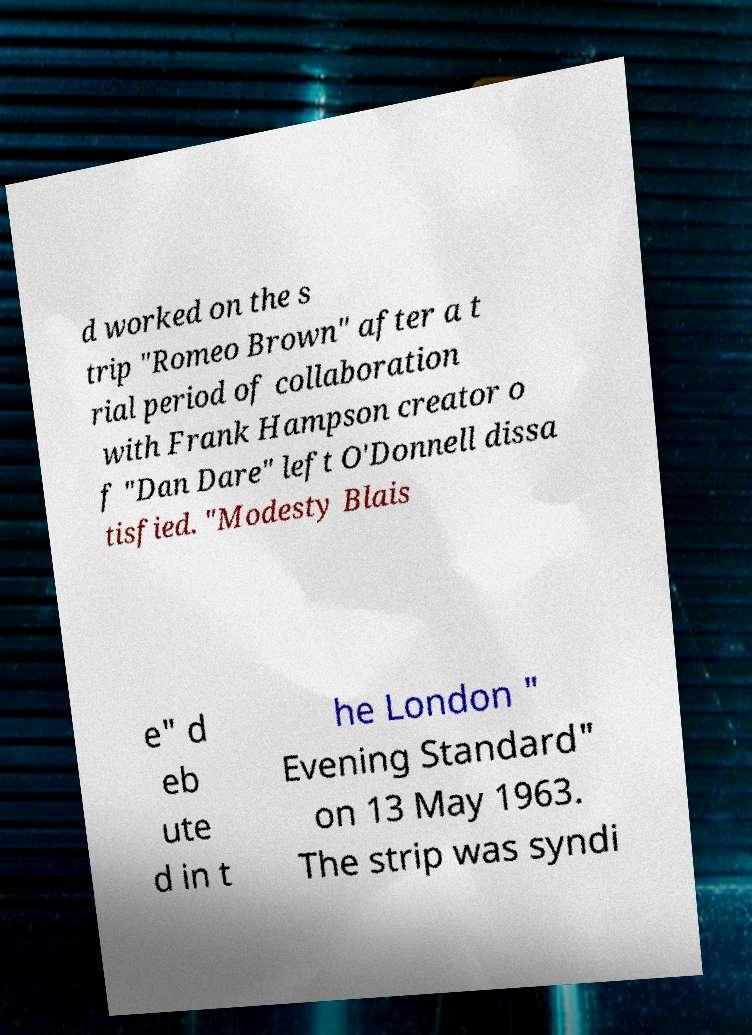There's text embedded in this image that I need extracted. Can you transcribe it verbatim? d worked on the s trip "Romeo Brown" after a t rial period of collaboration with Frank Hampson creator o f "Dan Dare" left O'Donnell dissa tisfied. "Modesty Blais e" d eb ute d in t he London " Evening Standard" on 13 May 1963. The strip was syndi 